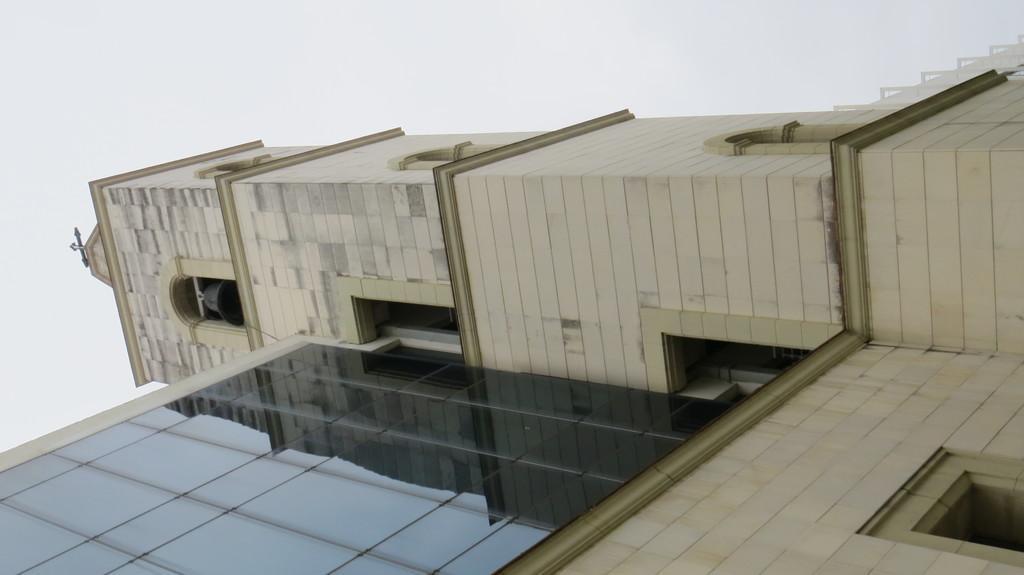Describe this image in one or two sentences. In this picture we can see church. On the left there is a bell. Here we can see cross mark. At the top we can see sky and clouds. 